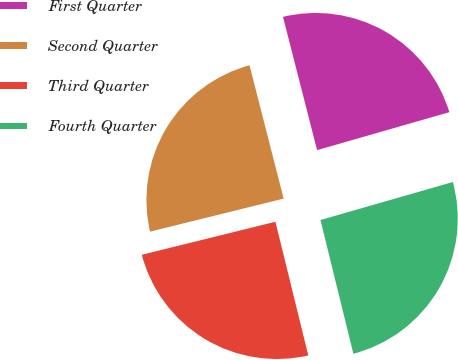<chart> <loc_0><loc_0><loc_500><loc_500><pie_chart><fcel>First Quarter<fcel>Second Quarter<fcel>Third Quarter<fcel>Fourth Quarter<nl><fcel>24.54%<fcel>24.87%<fcel>24.98%<fcel>25.61%<nl></chart> 